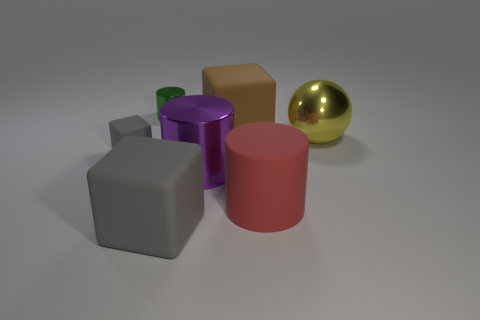Subtract all big cubes. How many cubes are left? 1 Add 1 big green shiny things. How many objects exist? 8 Subtract all brown blocks. How many blocks are left? 2 Subtract all cylinders. How many objects are left? 4 Subtract all brown blocks. How many red spheres are left? 0 Subtract all big yellow objects. Subtract all small cylinders. How many objects are left? 5 Add 5 big gray rubber objects. How many big gray rubber objects are left? 6 Add 2 big purple shiny cylinders. How many big purple shiny cylinders exist? 3 Subtract 1 gray cubes. How many objects are left? 6 Subtract 2 cylinders. How many cylinders are left? 1 